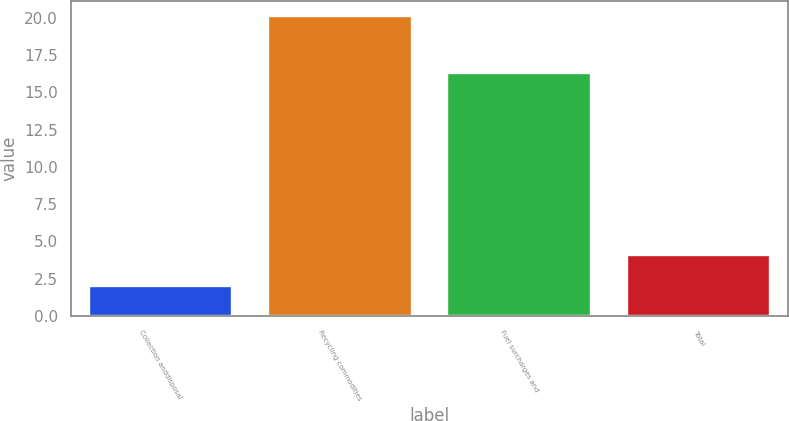Convert chart. <chart><loc_0><loc_0><loc_500><loc_500><bar_chart><fcel>Collection anddisposal<fcel>Recycling commodities<fcel>Fuel surcharges and<fcel>Total<nl><fcel>2<fcel>20.1<fcel>16.3<fcel>4.1<nl></chart> 